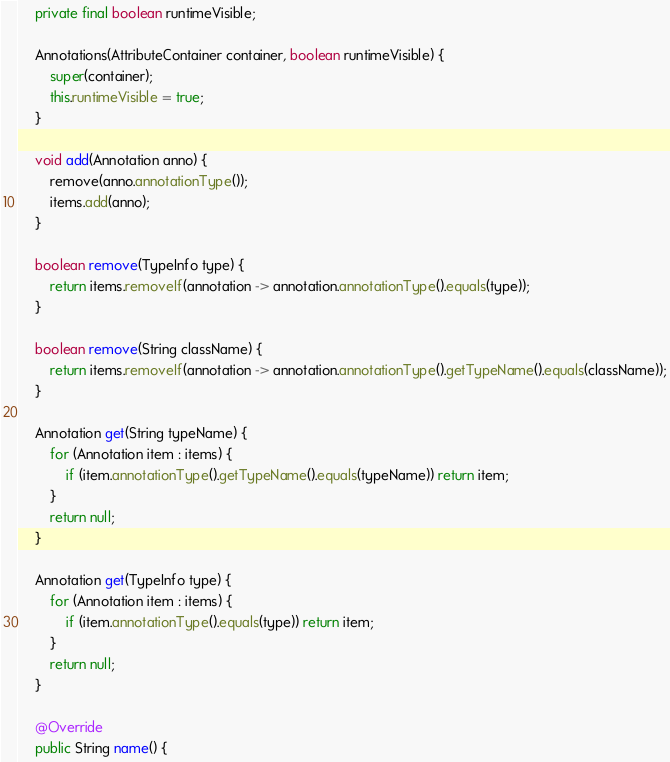<code> <loc_0><loc_0><loc_500><loc_500><_Java_>
    private final boolean runtimeVisible;

    Annotations(AttributeContainer container, boolean runtimeVisible) {
        super(container);
        this.runtimeVisible = true;
    }

    void add(Annotation anno) {
        remove(anno.annotationType());
        items.add(anno);
    }

    boolean remove(TypeInfo type) {
        return items.removeIf(annotation -> annotation.annotationType().equals(type));
    }

    boolean remove(String className) {
        return items.removeIf(annotation -> annotation.annotationType().getTypeName().equals(className));
    }

    Annotation get(String typeName) {
        for (Annotation item : items) {
            if (item.annotationType().getTypeName().equals(typeName)) return item;
        }
        return null;
    }
    
    Annotation get(TypeInfo type) {
        for (Annotation item : items) {
            if (item.annotationType().equals(type)) return item;
        }
        return null;
    }

    @Override
    public String name() {</code> 